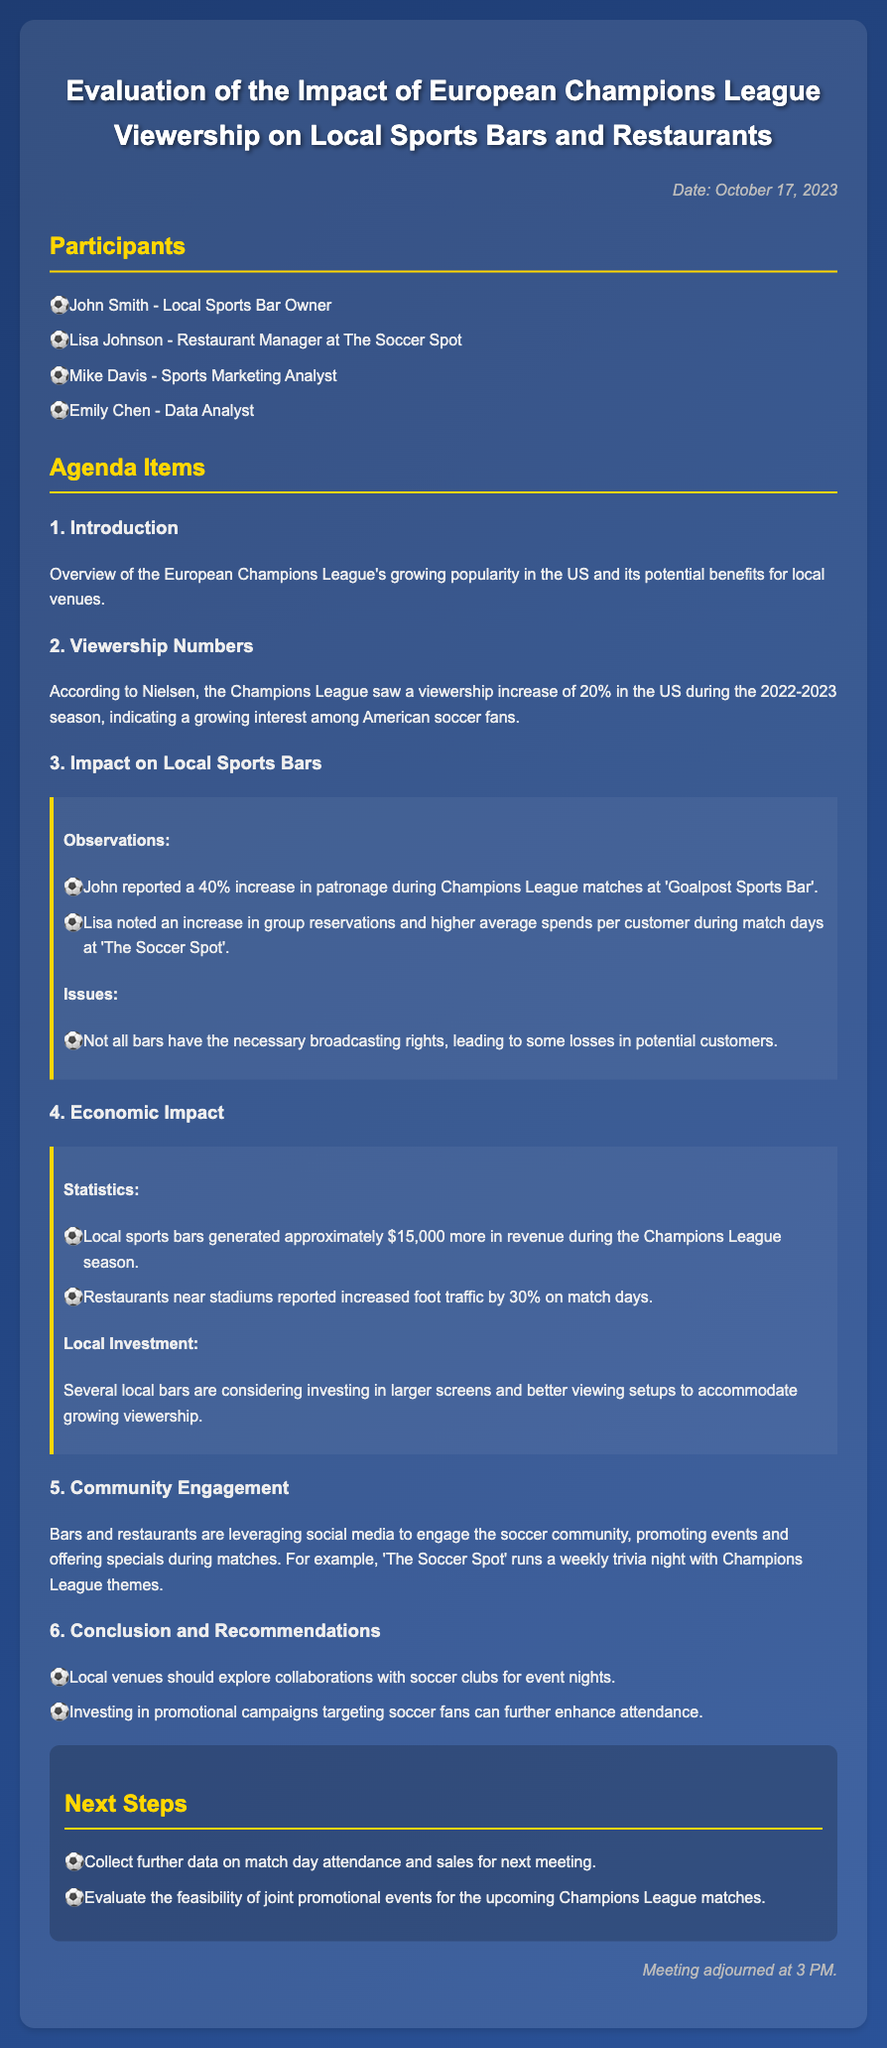What is the date of the meeting? The date of the meeting is mentioned at the top of the document as October 17, 2023.
Answer: October 17, 2023 Who is the sports marketing analyst? The document lists Mike Davis as the sports marketing analyst in the participants section.
Answer: Mike Davis What was the percentage increase in viewership during the 2022-2023 season? The document states that there was a 20% increase in viewership according to Nielsen during the 2022-2023 season.
Answer: 20% What was reported as the increase in patronage at 'Goalpost Sports Bar' during Champions League matches? John reported a 40% increase in patronage during Champions League matches at 'Goalpost Sports Bar'.
Answer: 40% How much additional revenue did local sports bars generate during the Champions League season? The document mentions that local sports bars generated approximately $15,000 more in revenue during the Champions League season.
Answer: $15,000 What community engagement strategy does 'The Soccer Spot' utilize? The document mentions that 'The Soccer Spot' runs a weekly trivia night with Champions League themes as a community engagement strategy.
Answer: Weekly trivia night Why are local bars considering investing in larger screens? Local bars are considering investing in larger screens and better viewing setups to accommodate growing viewership based on the document's information about increased patronage and interest.
Answer: To accommodate growing viewership What is one recommendation made for local venues? The document includes a recommendation for local venues to explore collaborations with soccer clubs for event nights.
Answer: Collaborations with soccer clubs 